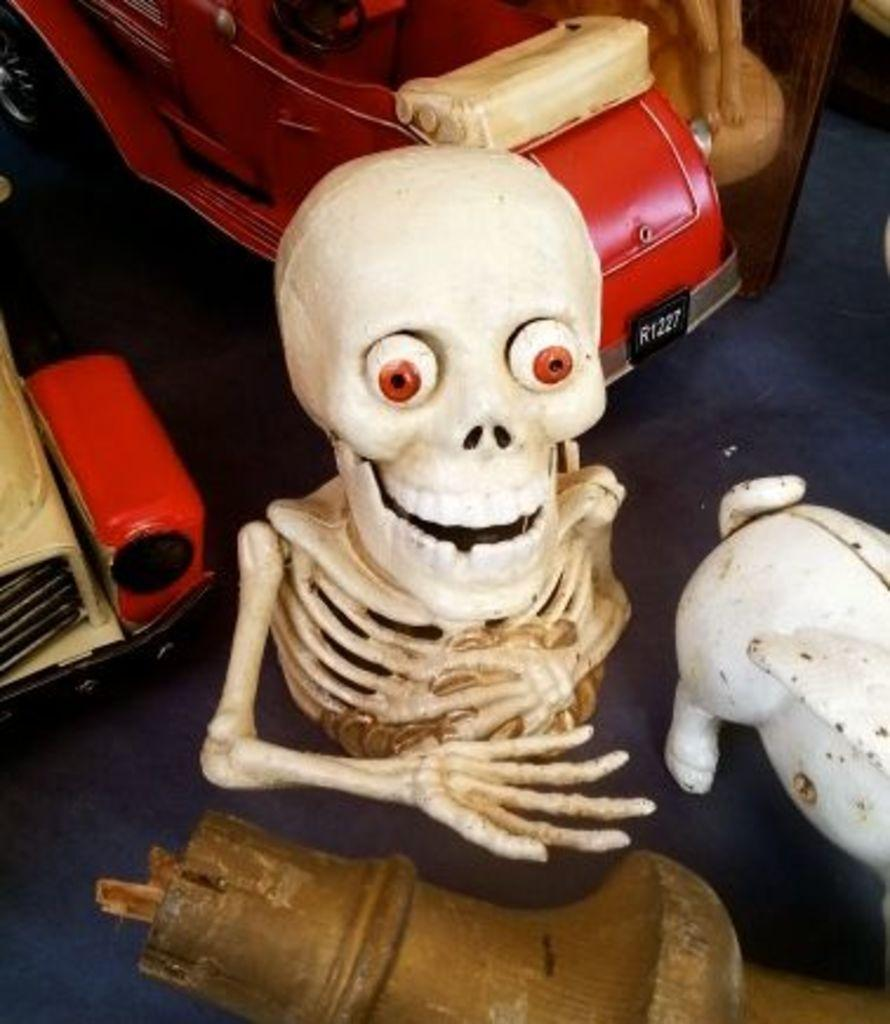What type of items can be seen in the image? There are toys and other objects in the image. Can you describe the skeleton in the image? The skeleton is placed on a surface in the image. Where is the parcel located in the image? There is no parcel present in the image. What type of card can be seen in the image? There is no card present in the image. 